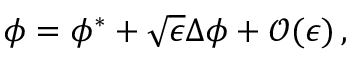<formula> <loc_0><loc_0><loc_500><loc_500>\begin{array} { r } { \phi = \phi ^ { * } + \sqrt { \epsilon } \Delta \phi + \mathcal { O } ( \epsilon ) \, , } \end{array}</formula> 